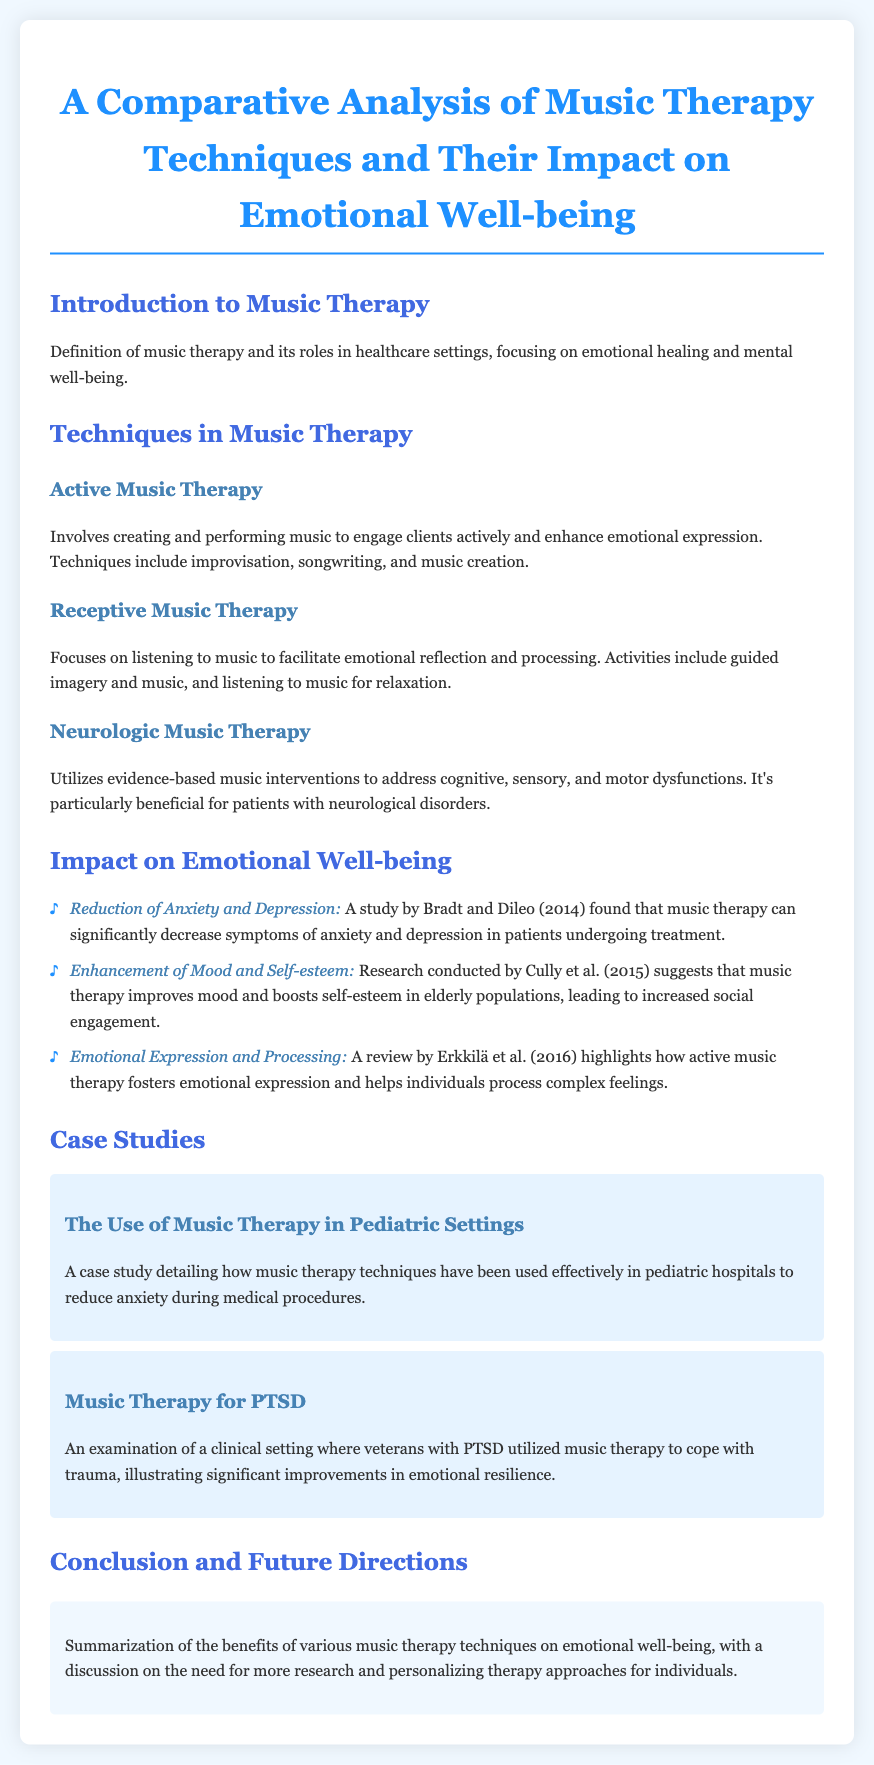What are the three main techniques in music therapy? The document lists three techniques: Active Music Therapy, Receptive Music Therapy, and Neurologic Music Therapy.
Answer: Active Music Therapy, Receptive Music Therapy, Neurologic Music Therapy What study found that music therapy reduces anxiety and depression? The document references a study by Bradt and Dileo from 2014 that found significant decreases in symptoms of anxiety and depression.
Answer: Bradt and Dileo (2014) What emotional benefits does music therapy provide to elderly populations? The research conducted by Cully et al. in 2015 suggests that music therapy improves mood and boosts self-esteem in elderly populations.
Answer: Improves mood and boosts self-esteem In which year did Cully et al. conduct their research on music therapy? The document states the year of Cully et al.'s research on music therapy as 2015.
Answer: 2015 What outcome is highlighted in the review by Erkkilä et al. in 2016? The review emphasizes how active music therapy fosters emotional expression and helps individuals process complex feelings.
Answer: Emotional expression and processing What type of therapy is used to help veterans cope with PTSD? The document mentions music therapy as a technique utilized by veterans with PTSD to cope with trauma.
Answer: Music therapy What is the primary focus of receptive music therapy? The document specifies that receptive music therapy focuses on listening to music to facilitate emotional reflection and processing.
Answer: Listening to music What is the case study about music therapy in pediatric settings focused on? The case study details the use of music therapy techniques in pediatric hospitals to reduce anxiety during medical procedures.
Answer: Reducing anxiety during medical procedures What is the conclusion regarding music therapy techniques and emotional well-being? The conclusion summarizes the benefits of music therapy techniques on emotional well-being and discusses the need for more research.
Answer: Benefits of various techniques on emotional well-being 